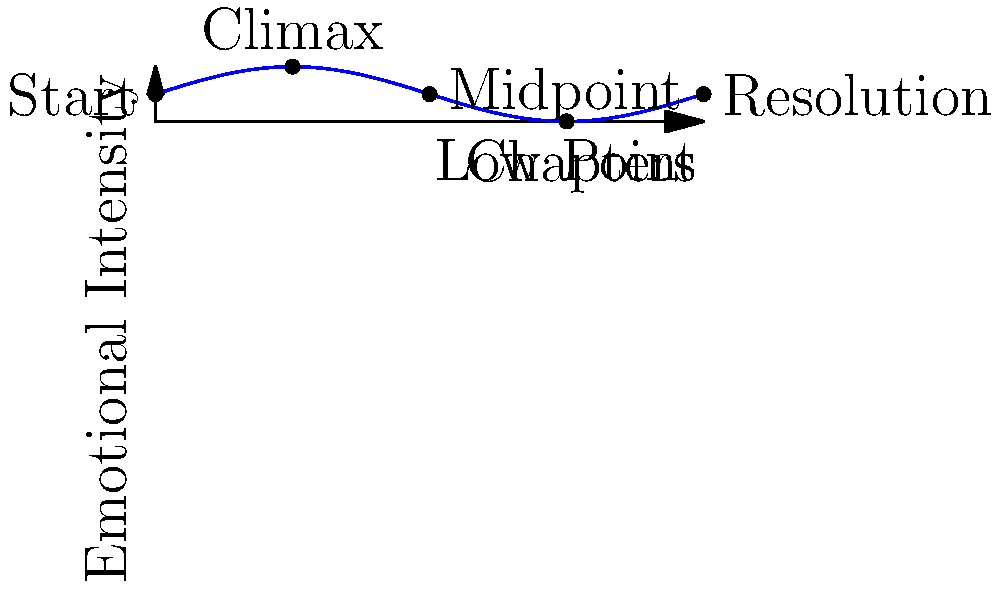In Alice Walker's "The Color Purple," analyze the emotional journey of the protagonist, Celie, using the line graph provided. Which chapter range represents the most significant emotional growth for Celie, and why might Walker have structured the narrative this way? To answer this question, let's analyze the graph step-by-step:

1. The x-axis represents the chapters of the novel, while the y-axis represents emotional intensity.

2. The graph shows five key points in Celie's emotional journey:
   - Start: Beginning of the novel
   - Climax: Highest point of emotional intensity
   - Midpoint: A return to the initial emotional state
   - Low Point: The lowest emotional point
   - Resolution: The emotional state at the end of the novel

3. The most significant emotional growth occurs between the Low Point and the Resolution, which is approximately between chapters 7.5 and 10.

4. This range shows a steep upward curve, indicating a rapid and substantial increase in emotional intensity.

5. Walker may have structured the narrative this way to:
   a) Create a powerful contrast between Celie's lowest point and her eventual empowerment
   b) Emphasize the transformative nature of Celie's journey
   c) Illustrate the idea that growth often follows significant challenges
   d) Provide a satisfying arc for readers, ending on a note of hope and resilience

6. This structure aligns with Walker's themes of personal growth, empowerment, and the triumph of the human spirit in the face of adversity.
Answer: Chapters 7.5-10; to emphasize transformative growth and resilience after adversity. 